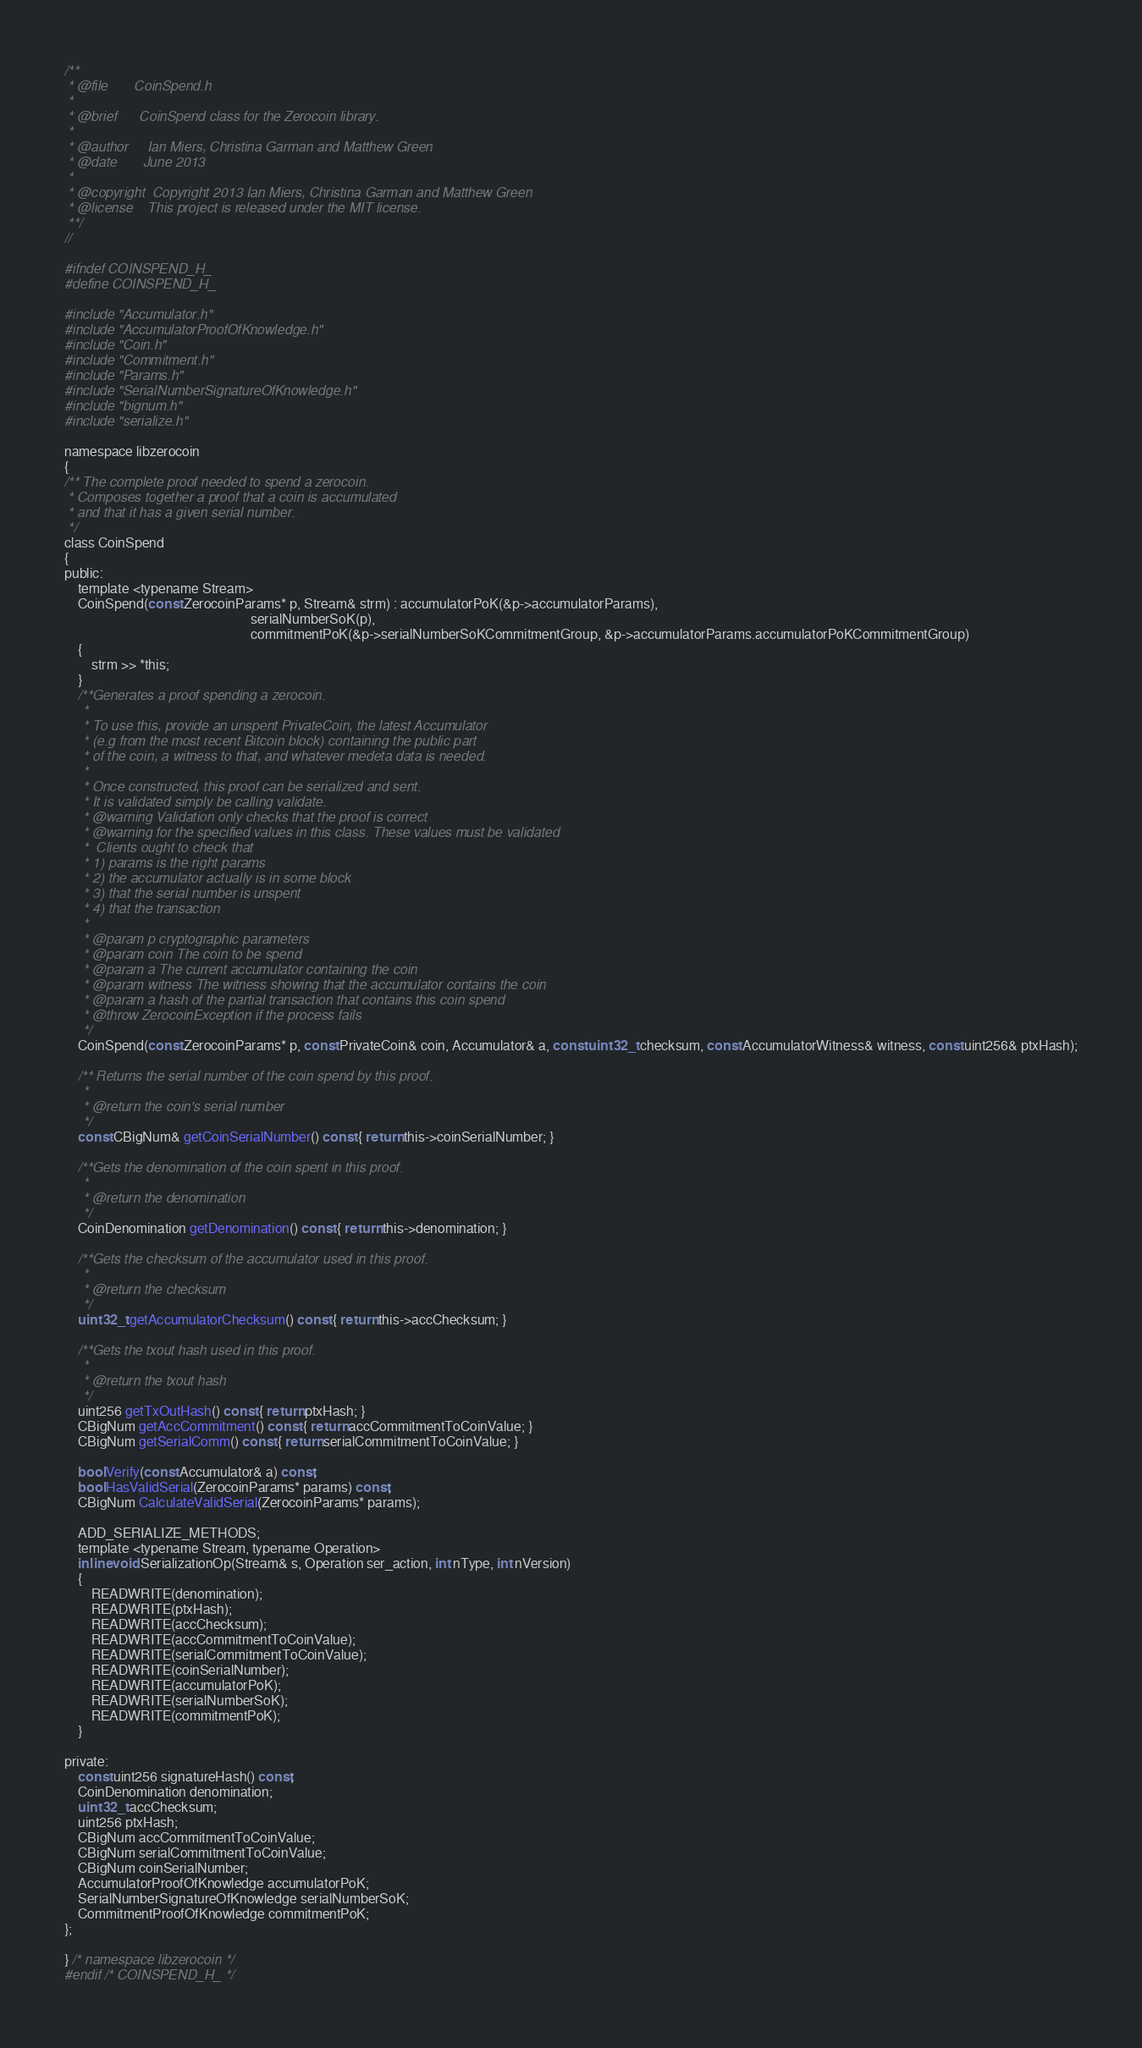<code> <loc_0><loc_0><loc_500><loc_500><_C_>/**
 * @file       CoinSpend.h
 *
 * @brief      CoinSpend class for the Zerocoin library.
 *
 * @author     Ian Miers, Christina Garman and Matthew Green
 * @date       June 2013
 *
 * @copyright  Copyright 2013 Ian Miers, Christina Garman and Matthew Green
 * @license    This project is released under the MIT license.
 **/
// 

#ifndef COINSPEND_H_
#define COINSPEND_H_

#include "Accumulator.h"
#include "AccumulatorProofOfKnowledge.h"
#include "Coin.h"
#include "Commitment.h"
#include "Params.h"
#include "SerialNumberSignatureOfKnowledge.h"
#include "bignum.h"
#include "serialize.h"

namespace libzerocoin
{
/** The complete proof needed to spend a zerocoin.
 * Composes together a proof that a coin is accumulated
 * and that it has a given serial number.
 */
class CoinSpend
{
public:
    template <typename Stream>
    CoinSpend(const ZerocoinParams* p, Stream& strm) : accumulatorPoK(&p->accumulatorParams),
                                                       serialNumberSoK(p),
                                                       commitmentPoK(&p->serialNumberSoKCommitmentGroup, &p->accumulatorParams.accumulatorPoKCommitmentGroup)
    {
        strm >> *this;
    }
    /**Generates a proof spending a zerocoin.
	 *
	 * To use this, provide an unspent PrivateCoin, the latest Accumulator
	 * (e.g from the most recent Bitcoin block) containing the public part
	 * of the coin, a witness to that, and whatever medeta data is needed.
	 *
	 * Once constructed, this proof can be serialized and sent.
	 * It is validated simply be calling validate.
	 * @warning Validation only checks that the proof is correct
	 * @warning for the specified values in this class. These values must be validated
	 *  Clients ought to check that
	 * 1) params is the right params
	 * 2) the accumulator actually is in some block
	 * 3) that the serial number is unspent
	 * 4) that the transaction
	 *
	 * @param p cryptographic parameters
	 * @param coin The coin to be spend
	 * @param a The current accumulator containing the coin
	 * @param witness The witness showing that the accumulator contains the coin
	 * @param a hash of the partial transaction that contains this coin spend
	 * @throw ZerocoinException if the process fails
	 */
    CoinSpend(const ZerocoinParams* p, const PrivateCoin& coin, Accumulator& a, const uint32_t checksum, const AccumulatorWitness& witness, const uint256& ptxHash);

    /** Returns the serial number of the coin spend by this proof.
	 *
	 * @return the coin's serial number
	 */
    const CBigNum& getCoinSerialNumber() const { return this->coinSerialNumber; }

    /**Gets the denomination of the coin spent in this proof.
	 *
	 * @return the denomination
	 */
    CoinDenomination getDenomination() const { return this->denomination; }

    /**Gets the checksum of the accumulator used in this proof.
	 *
	 * @return the checksum
	 */
    uint32_t getAccumulatorChecksum() const { return this->accChecksum; }

    /**Gets the txout hash used in this proof.
	 *
	 * @return the txout hash
	 */
    uint256 getTxOutHash() const { return ptxHash; }
    CBigNum getAccCommitment() const { return accCommitmentToCoinValue; }
    CBigNum getSerialComm() const { return serialCommitmentToCoinValue; }

    bool Verify(const Accumulator& a) const;
    bool HasValidSerial(ZerocoinParams* params) const;
    CBigNum CalculateValidSerial(ZerocoinParams* params);

    ADD_SERIALIZE_METHODS;
    template <typename Stream, typename Operation>
    inline void SerializationOp(Stream& s, Operation ser_action, int nType, int nVersion)
    {
        READWRITE(denomination);
        READWRITE(ptxHash);
        READWRITE(accChecksum);
        READWRITE(accCommitmentToCoinValue);
        READWRITE(serialCommitmentToCoinValue);
        READWRITE(coinSerialNumber);
        READWRITE(accumulatorPoK);
        READWRITE(serialNumberSoK);
        READWRITE(commitmentPoK);
    }

private:
    const uint256 signatureHash() const;
    CoinDenomination denomination;
    uint32_t accChecksum;
    uint256 ptxHash;
    CBigNum accCommitmentToCoinValue;
    CBigNum serialCommitmentToCoinValue;
    CBigNum coinSerialNumber;
    AccumulatorProofOfKnowledge accumulatorPoK;
    SerialNumberSignatureOfKnowledge serialNumberSoK;
    CommitmentProofOfKnowledge commitmentPoK;
};

} /* namespace libzerocoin */
#endif /* COINSPEND_H_ */
</code> 